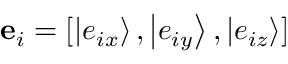<formula> <loc_0><loc_0><loc_500><loc_500>{ { e } _ { i } } = [ \left | { { e _ { i x } } } \right \rangle , \left | { { e _ { i y } } } \right \rangle , \left | { { e _ { i z } } } \right \rangle ]</formula> 